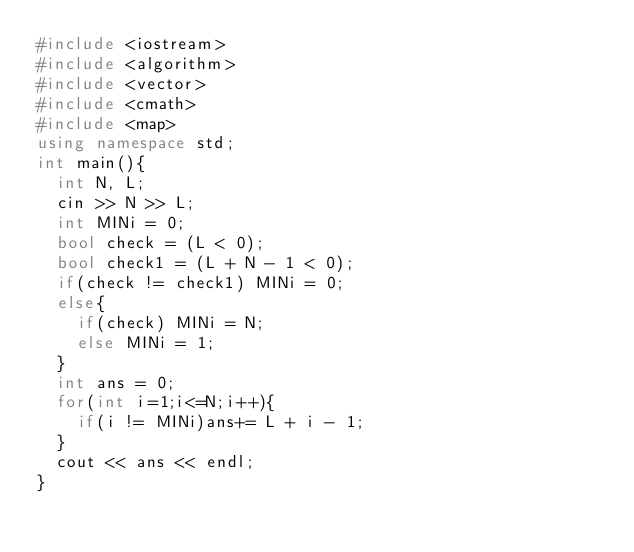<code> <loc_0><loc_0><loc_500><loc_500><_C++_>#include <iostream>
#include <algorithm>
#include <vector>
#include <cmath>
#include <map>
using namespace std;
int main(){
	int N, L;
	cin >> N >> L;
	int MINi = 0;
	bool check = (L < 0);
	bool check1 = (L + N - 1 < 0);
	if(check != check1) MINi = 0;
	else{
		if(check) MINi = N;
		else MINi = 1;
	}
	int ans = 0;
	for(int i=1;i<=N;i++){
		if(i != MINi)ans+= L + i - 1;
	}
	cout << ans << endl;
}</code> 